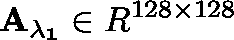<formula> <loc_0><loc_0><loc_500><loc_500>A _ { \lambda _ { 1 } } \in \mathbb { R } ^ { 1 2 8 \times 1 2 8 }</formula> 